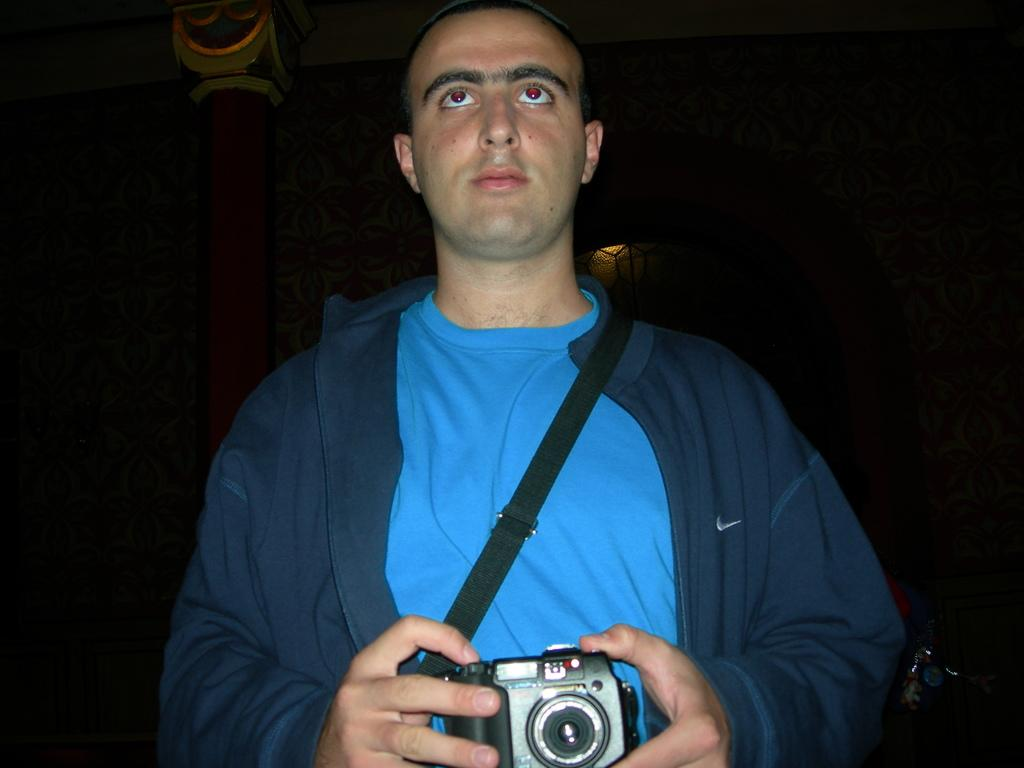Who is present in the image? There is a man in the picture. What is the man doing in the image? The man is standing and holding a camera with both hands. What is the man wearing in the image? The man is wearing a blank (possibly a typo, should be "blanket" or "jacket"). How many notebooks can be seen in the image? There are no notebooks present in the image. What is the fifth item in the image? The image only contains three items: the man, the camera, and the man's clothing. There is no fifth item. 